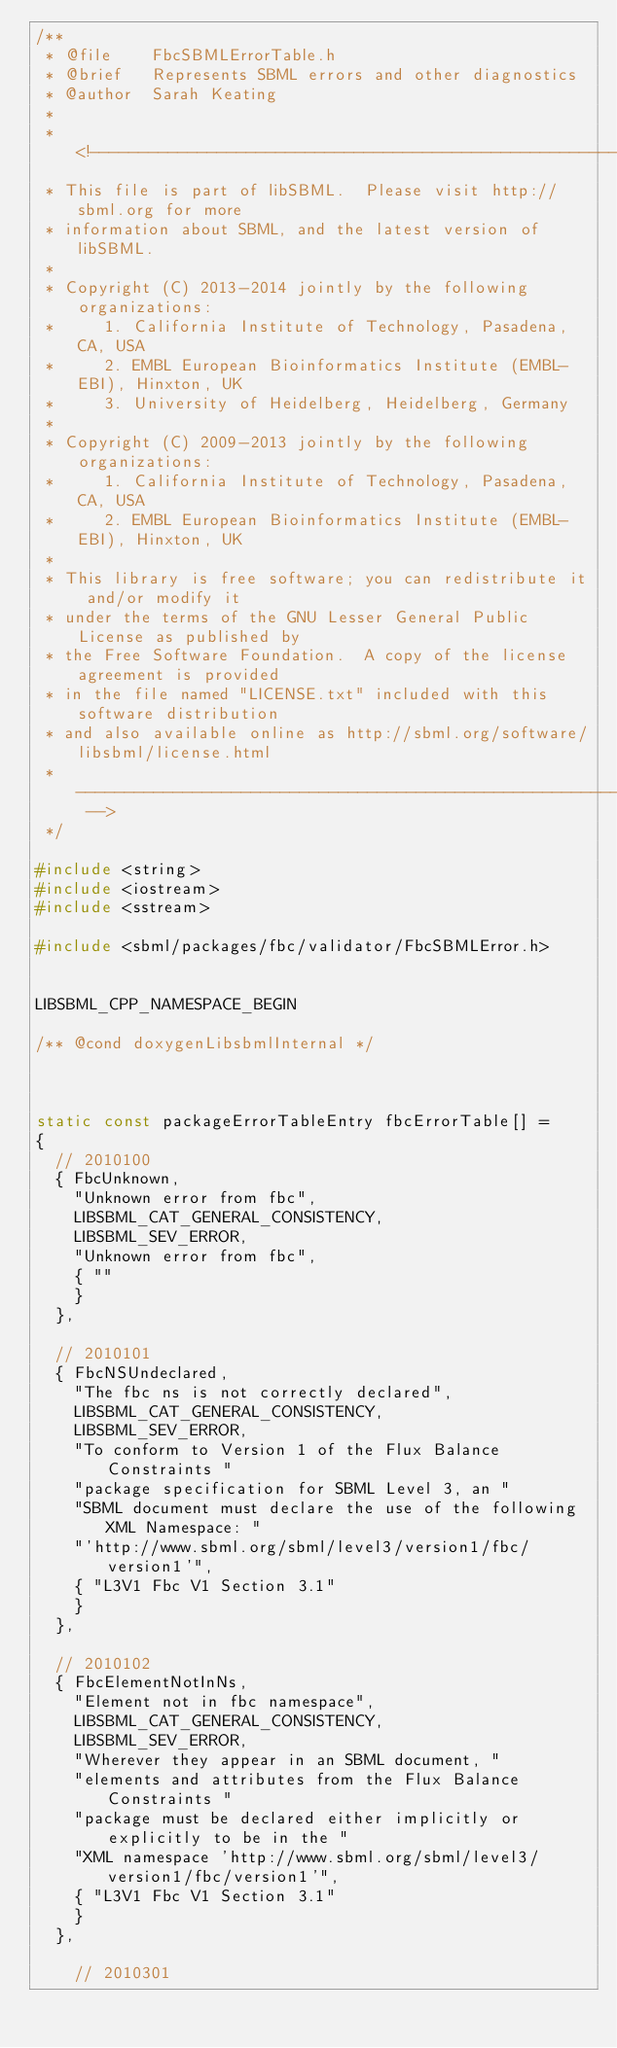Convert code to text. <code><loc_0><loc_0><loc_500><loc_500><_C_>/**
 * @file    FbcSBMLErrorTable.h
 * @brief   Represents SBML errors and other diagnostics
 * @author  Sarah Keating
 * 
 * <!--------------------------------------------------------------------------
 * This file is part of libSBML.  Please visit http://sbml.org for more
 * information about SBML, and the latest version of libSBML.
 * 
 * Copyright (C) 2013-2014 jointly by the following organizations:
 *     1. California Institute of Technology, Pasadena, CA, USA
 *     2. EMBL European Bioinformatics Institute (EMBL-EBI), Hinxton, UK
 *     3. University of Heidelberg, Heidelberg, Germany
 * 
 * Copyright (C) 2009-2013 jointly by the following organizations: 
 *     1. California Institute of Technology, Pasadena, CA, USA
 *     2. EMBL European Bioinformatics Institute (EMBL-EBI), Hinxton, UK
 *
 * This library is free software; you can redistribute it and/or modify it
 * under the terms of the GNU Lesser General Public License as published by
 * the Free Software Foundation.  A copy of the license agreement is provided
 * in the file named "LICENSE.txt" included with this software distribution
 * and also available online as http://sbml.org/software/libsbml/license.html
 * ---------------------------------------------------------------------- -->
 */
 
#include <string>
#include <iostream>
#include <sstream>

#include <sbml/packages/fbc/validator/FbcSBMLError.h>


LIBSBML_CPP_NAMESPACE_BEGIN

/** @cond doxygenLibsbmlInternal */



static const packageErrorTableEntry fbcErrorTable[] =
{
  // 2010100
  { FbcUnknown, 
    "Unknown error from fbc",
    LIBSBML_CAT_GENERAL_CONSISTENCY, 
    LIBSBML_SEV_ERROR,
    "Unknown error from fbc",
    { ""
    }
  },

  // 2010101
  { FbcNSUndeclared, 
    "The fbc ns is not correctly declared",
    LIBSBML_CAT_GENERAL_CONSISTENCY, 
    LIBSBML_SEV_ERROR,
    "To conform to Version 1 of the Flux Balance Constraints "
    "package specification for SBML Level 3, an "
    "SBML document must declare the use of the following XML Namespace: "
    "'http://www.sbml.org/sbml/level3/version1/fbc/version1'",
    { "L3V1 Fbc V1 Section 3.1"
    }
  },

  // 2010102
  { FbcElementNotInNs, 
    "Element not in fbc namespace",
    LIBSBML_CAT_GENERAL_CONSISTENCY, 
    LIBSBML_SEV_ERROR,
    "Wherever they appear in an SBML document, "
    "elements and attributes from the Flux Balance Constraints "
    "package must be declared either implicitly or explicitly to be in the "
    "XML namespace 'http://www.sbml.org/sbml/level3/version1/fbc/version1'",
    { "L3V1 Fbc V1 Section 3.1"
    }
  },

    // 2010301</code> 